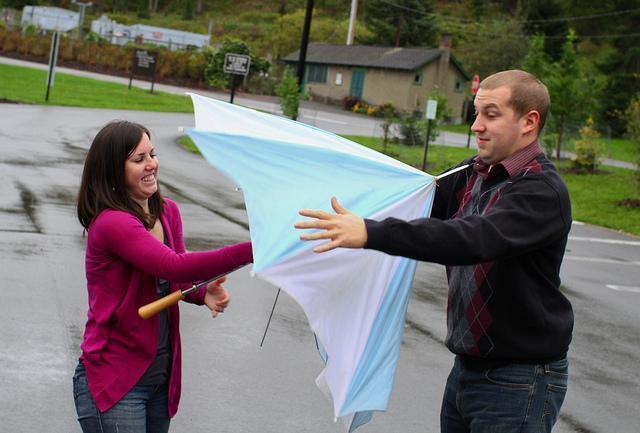How many umbrellas are pictured?
Give a very brief answer. 1. How many people are there?
Give a very brief answer. 2. How many motorcycles are in the showroom?
Give a very brief answer. 0. 